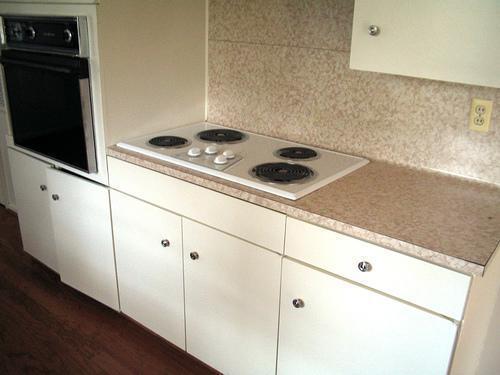How many cupboard doors are open?
Give a very brief answer. 1. How many ovens are there?
Give a very brief answer. 2. 